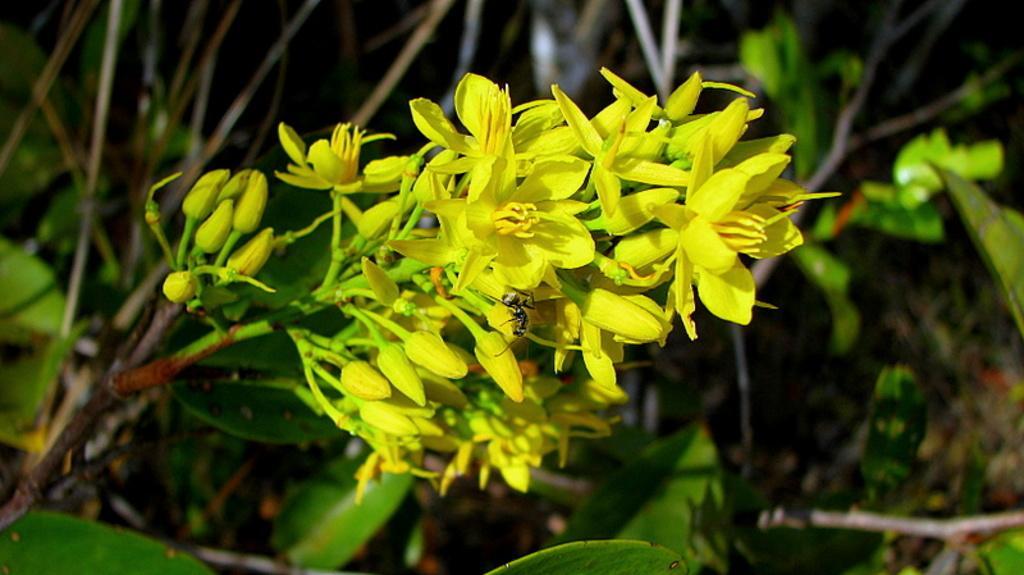How would you summarize this image in a sentence or two? In this image I can see few yellow colour flowers, number of yellow buds, few green colour leaves and stems. I can also see this image is little bit blurry. 